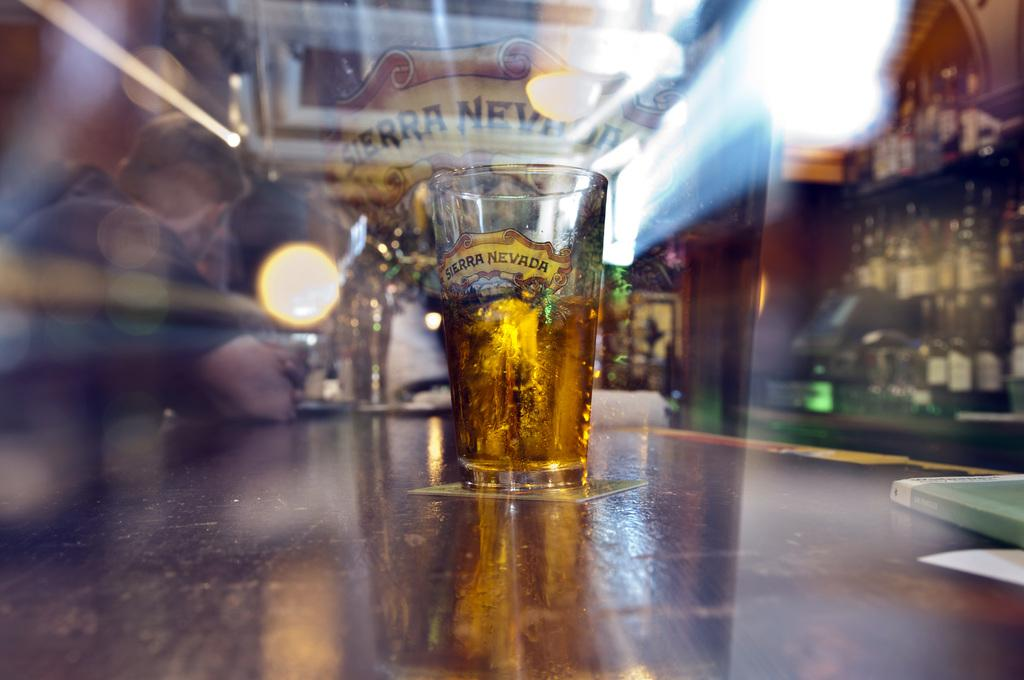<image>
Give a short and clear explanation of the subsequent image. A glass on a table in a bar of Sierra Nevada. 